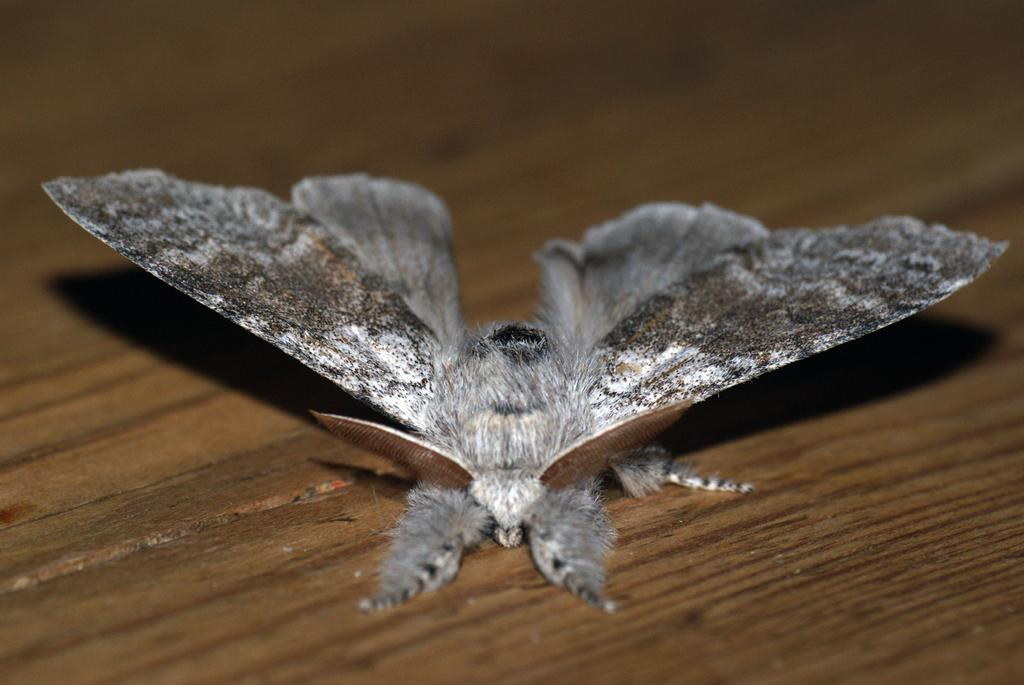What type of creature is present in the image? There is an insect in the picture. What color is the insect? The insect is grey in color. What type of surface is at the bottom of the picture? There is a wooden floor at the bottom of the picture. How many cherries can be seen in the hand of the person in the image? There is no person or cherries present in the image; it only features an insect and a wooden floor. 